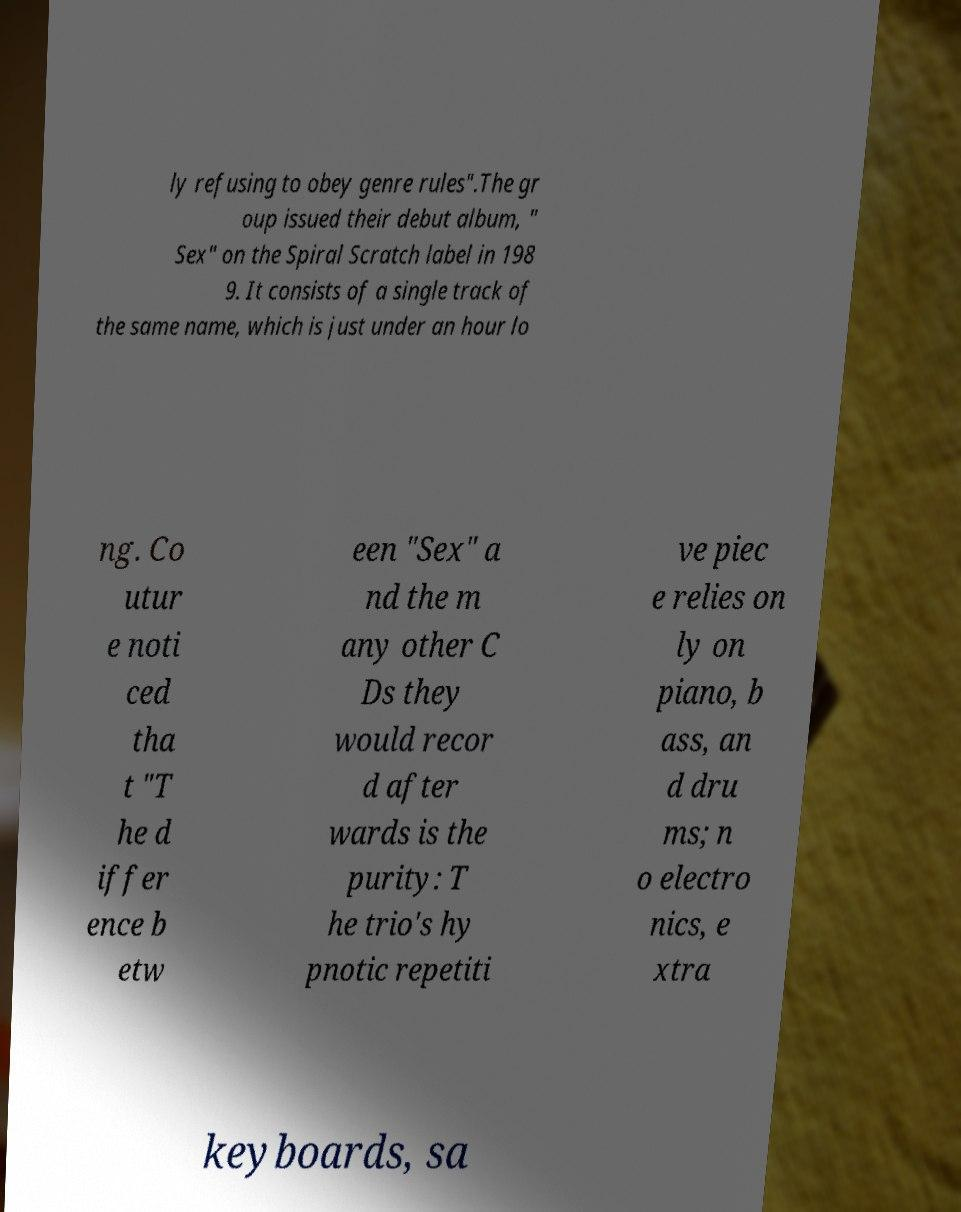Can you read and provide the text displayed in the image?This photo seems to have some interesting text. Can you extract and type it out for me? ly refusing to obey genre rules".The gr oup issued their debut album, " Sex" on the Spiral Scratch label in 198 9. It consists of a single track of the same name, which is just under an hour lo ng. Co utur e noti ced tha t "T he d iffer ence b etw een "Sex" a nd the m any other C Ds they would recor d after wards is the purity: T he trio's hy pnotic repetiti ve piec e relies on ly on piano, b ass, an d dru ms; n o electro nics, e xtra keyboards, sa 